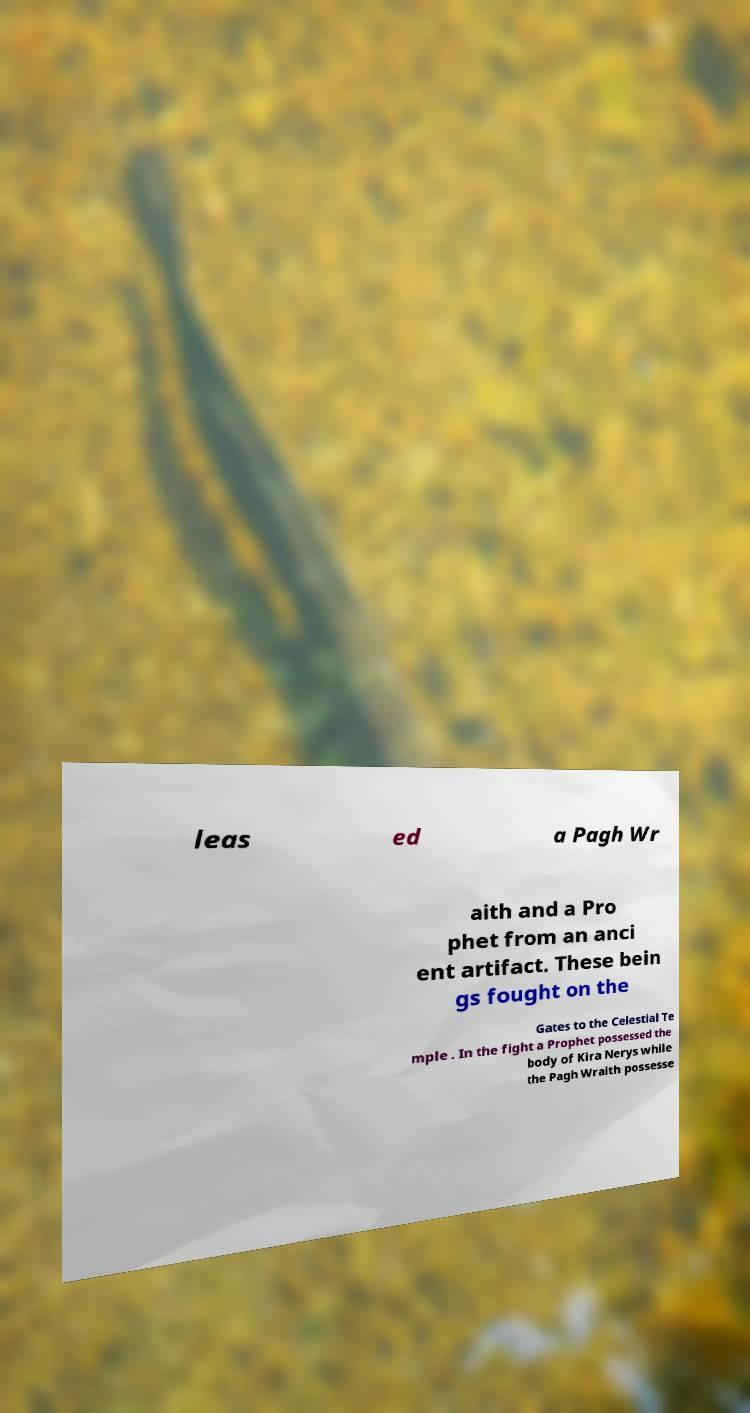I need the written content from this picture converted into text. Can you do that? leas ed a Pagh Wr aith and a Pro phet from an anci ent artifact. These bein gs fought on the Gates to the Celestial Te mple . In the fight a Prophet possessed the body of Kira Nerys while the Pagh Wraith possesse 